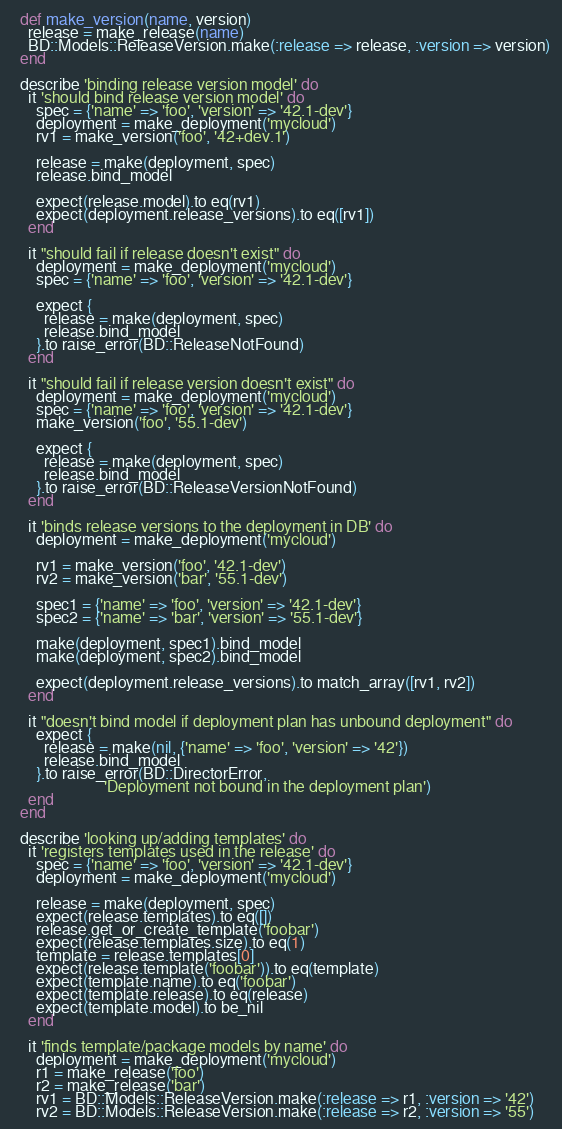<code> <loc_0><loc_0><loc_500><loc_500><_Ruby_>  def make_version(name, version)
    release = make_release(name)
    BD::Models::ReleaseVersion.make(:release => release, :version => version)
  end

  describe 'binding release version model' do
    it 'should bind release version model' do
      spec = {'name' => 'foo', 'version' => '42.1-dev'}
      deployment = make_deployment('mycloud')
      rv1 = make_version('foo', '42+dev.1')

      release = make(deployment, spec)
      release.bind_model

      expect(release.model).to eq(rv1)
      expect(deployment.release_versions).to eq([rv1])
    end

    it "should fail if release doesn't exist" do
      deployment = make_deployment('mycloud')
      spec = {'name' => 'foo', 'version' => '42.1-dev'}

      expect {
        release = make(deployment, spec)
        release.bind_model
      }.to raise_error(BD::ReleaseNotFound)
    end

    it "should fail if release version doesn't exist" do
      deployment = make_deployment('mycloud')
      spec = {'name' => 'foo', 'version' => '42.1-dev'}
      make_version('foo', '55.1-dev')

      expect {
        release = make(deployment, spec)
        release.bind_model
      }.to raise_error(BD::ReleaseVersionNotFound)
    end

    it 'binds release versions to the deployment in DB' do
      deployment = make_deployment('mycloud')

      rv1 = make_version('foo', '42.1-dev')
      rv2 = make_version('bar', '55.1-dev')

      spec1 = {'name' => 'foo', 'version' => '42.1-dev'}
      spec2 = {'name' => 'bar', 'version' => '55.1-dev'}

      make(deployment, spec1).bind_model
      make(deployment, spec2).bind_model

      expect(deployment.release_versions).to match_array([rv1, rv2])
    end

    it "doesn't bind model if deployment plan has unbound deployment" do
      expect {
        release = make(nil, {'name' => 'foo', 'version' => '42'})
        release.bind_model
      }.to raise_error(BD::DirectorError,
                       'Deployment not bound in the deployment plan')
    end
  end

  describe 'looking up/adding templates' do
    it 'registers templates used in the release' do
      spec = {'name' => 'foo', 'version' => '42.1-dev'}
      deployment = make_deployment('mycloud')

      release = make(deployment, spec)
      expect(release.templates).to eq([])
      release.get_or_create_template('foobar')
      expect(release.templates.size).to eq(1)
      template = release.templates[0]
      expect(release.template('foobar')).to eq(template)
      expect(template.name).to eq('foobar')
      expect(template.release).to eq(release)
      expect(template.model).to be_nil
    end

    it 'finds template/package models by name' do
      deployment = make_deployment('mycloud')
      r1 = make_release('foo')
      r2 = make_release('bar')
      rv1 = BD::Models::ReleaseVersion.make(:release => r1, :version => '42')
      rv2 = BD::Models::ReleaseVersion.make(:release => r2, :version => '55')
</code> 